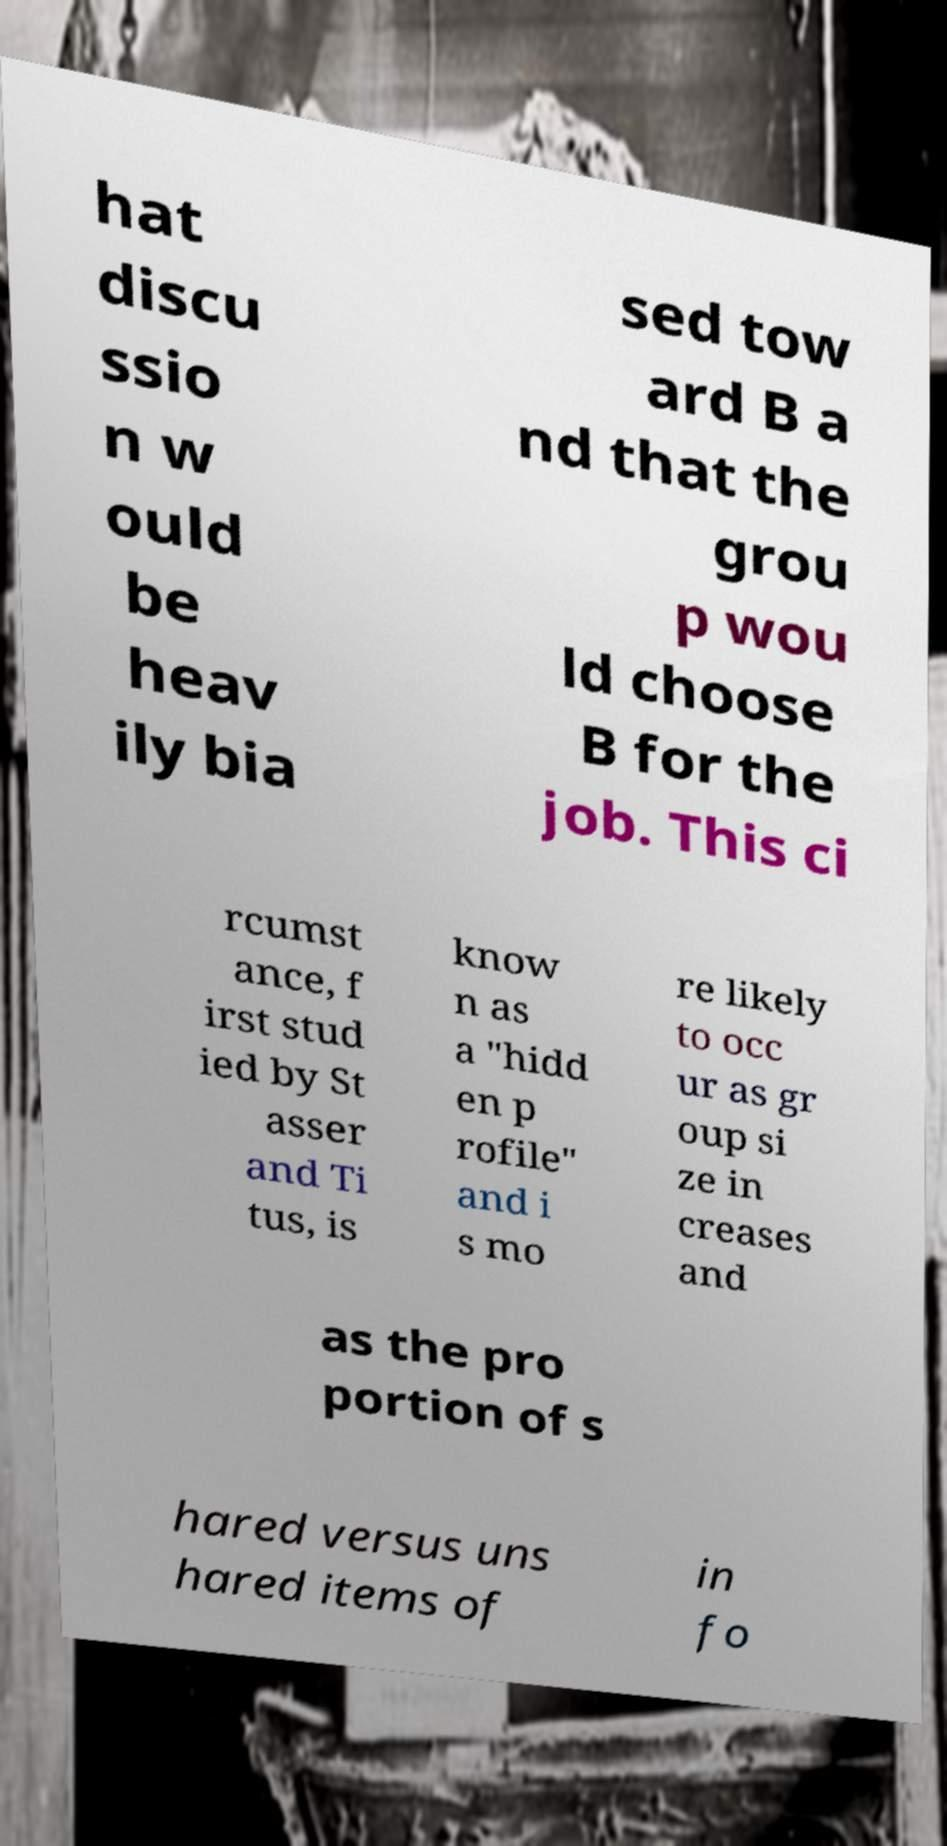Can you accurately transcribe the text from the provided image for me? hat discu ssio n w ould be heav ily bia sed tow ard B a nd that the grou p wou ld choose B for the job. This ci rcumst ance, f irst stud ied by St asser and Ti tus, is know n as a "hidd en p rofile" and i s mo re likely to occ ur as gr oup si ze in creases and as the pro portion of s hared versus uns hared items of in fo 